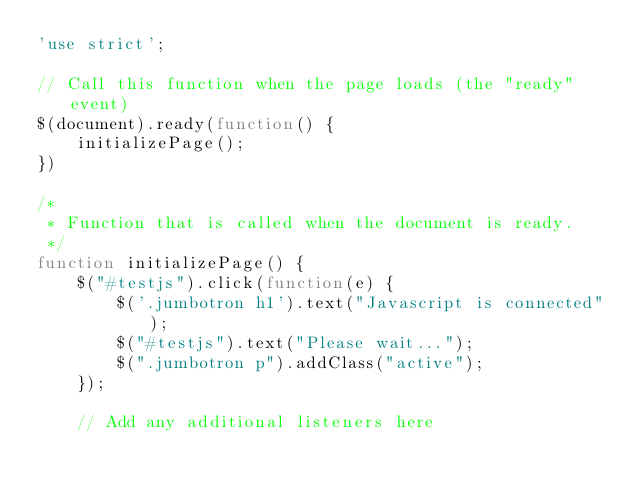Convert code to text. <code><loc_0><loc_0><loc_500><loc_500><_JavaScript_>'use strict';

// Call this function when the page loads (the "ready" event)
$(document).ready(function() {
	initializePage();
})

/*
 * Function that is called when the document is ready.
 */
function initializePage() {
	$("#testjs").click(function(e) {
		$('.jumbotron h1').text("Javascript is connected");
		$("#testjs").text("Please wait...");
		$(".jumbotron p").addClass("active");
	});

	// Add any additional listeners here</code> 